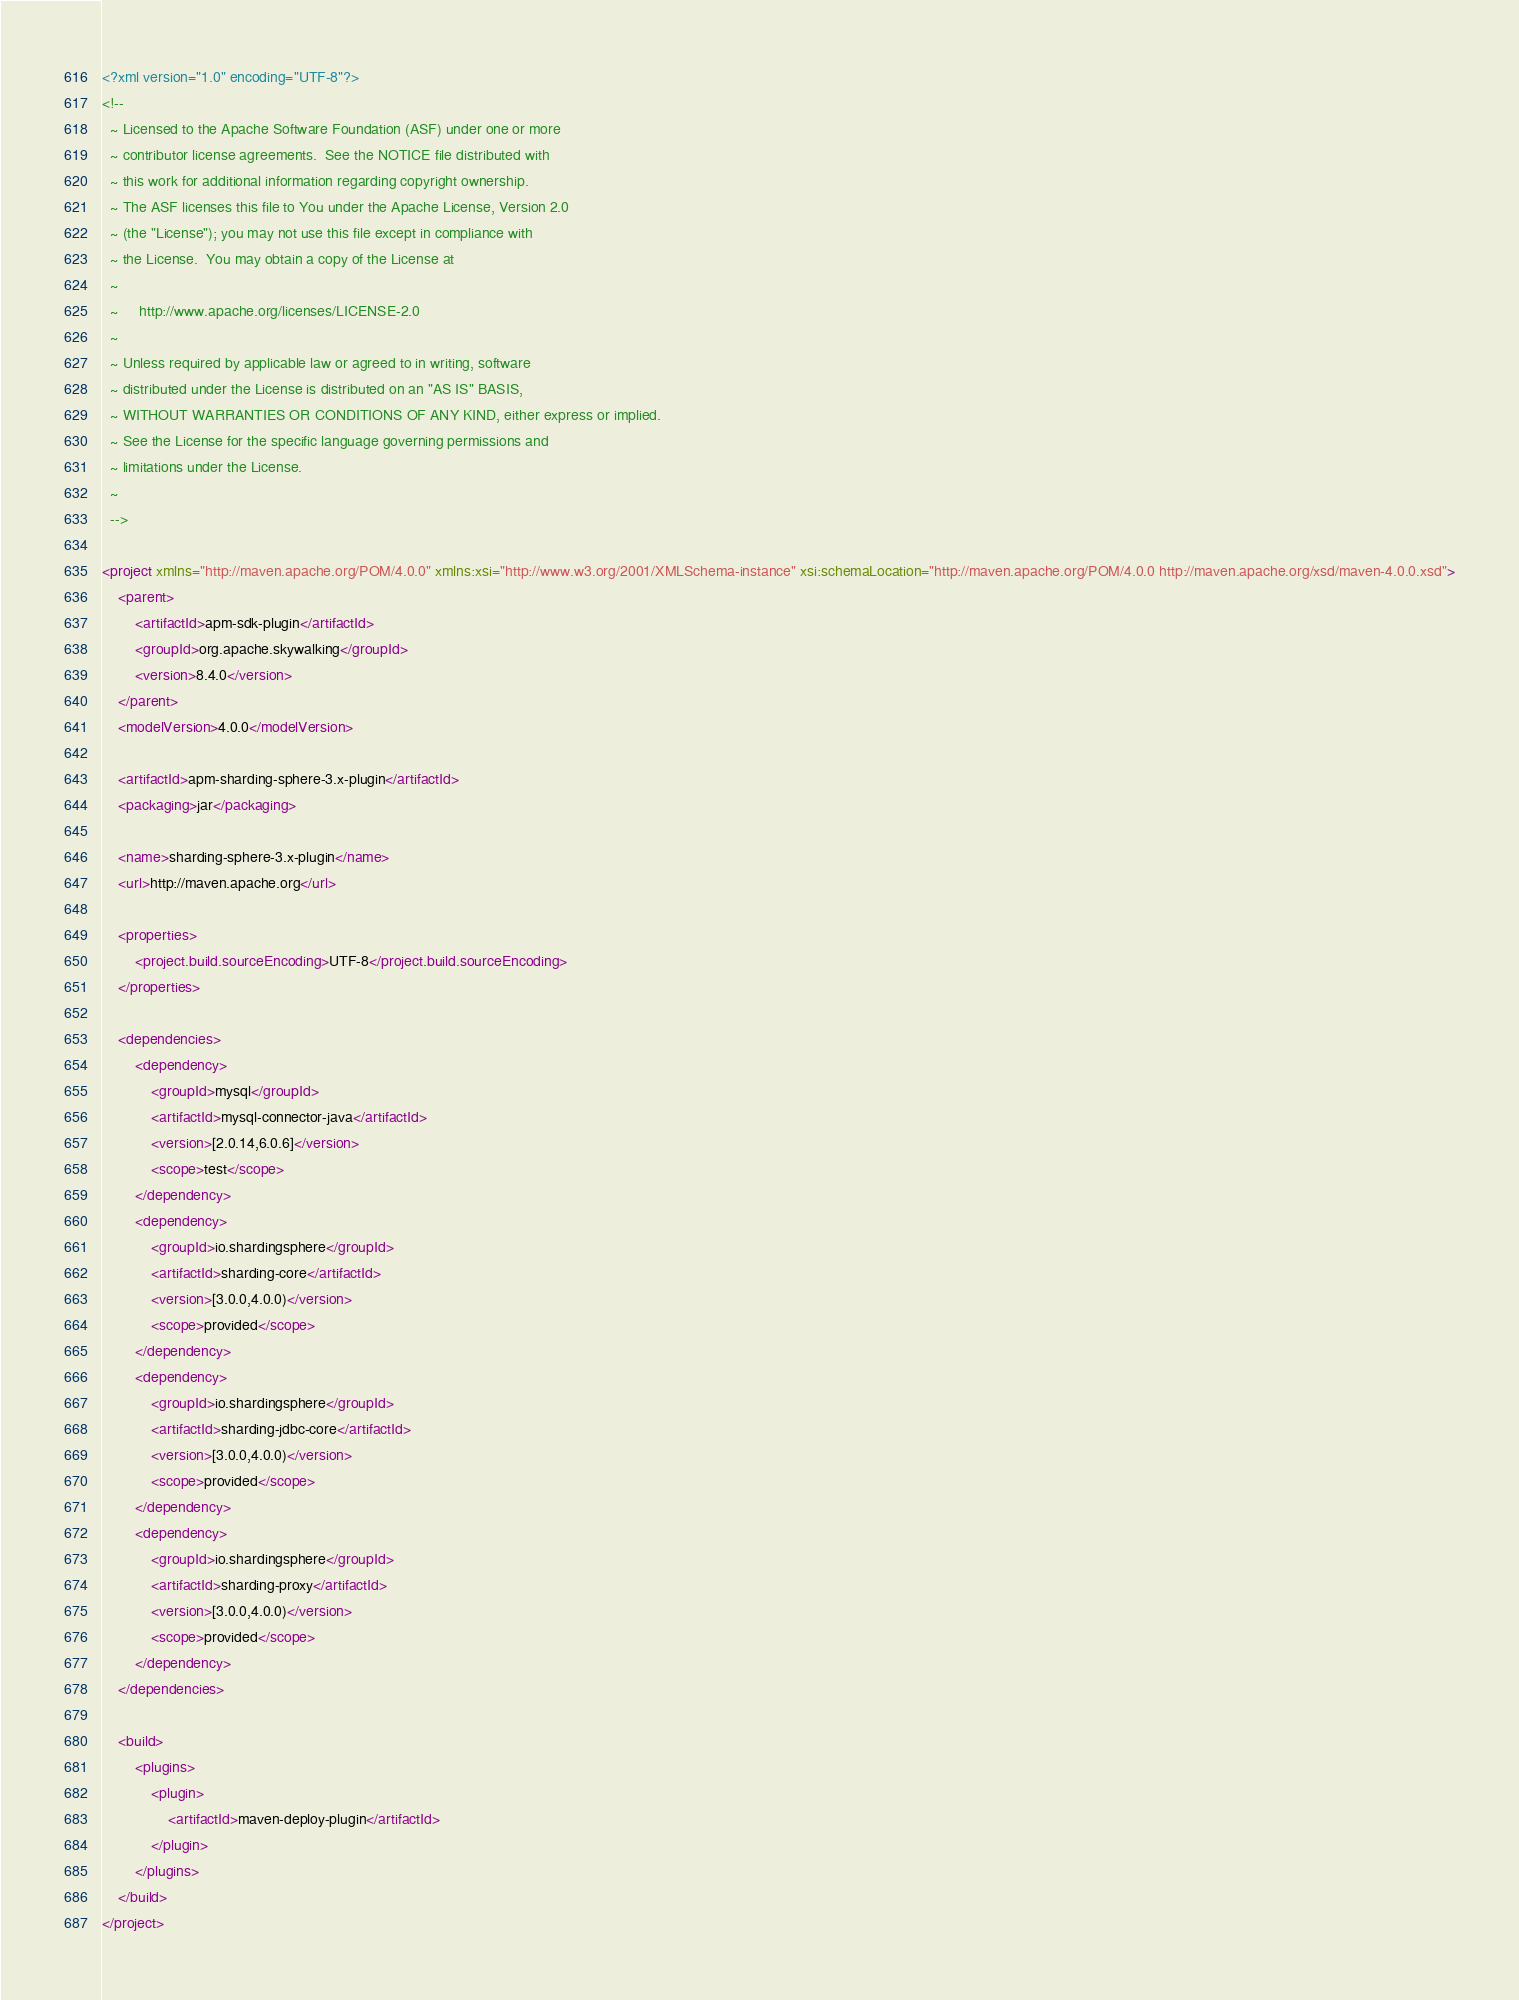Convert code to text. <code><loc_0><loc_0><loc_500><loc_500><_XML_><?xml version="1.0" encoding="UTF-8"?>
<!--
  ~ Licensed to the Apache Software Foundation (ASF) under one or more
  ~ contributor license agreements.  See the NOTICE file distributed with
  ~ this work for additional information regarding copyright ownership.
  ~ The ASF licenses this file to You under the Apache License, Version 2.0
  ~ (the "License"); you may not use this file except in compliance with
  ~ the License.  You may obtain a copy of the License at
  ~
  ~     http://www.apache.org/licenses/LICENSE-2.0
  ~
  ~ Unless required by applicable law or agreed to in writing, software
  ~ distributed under the License is distributed on an "AS IS" BASIS,
  ~ WITHOUT WARRANTIES OR CONDITIONS OF ANY KIND, either express or implied.
  ~ See the License for the specific language governing permissions and
  ~ limitations under the License.
  ~
  -->

<project xmlns="http://maven.apache.org/POM/4.0.0" xmlns:xsi="http://www.w3.org/2001/XMLSchema-instance" xsi:schemaLocation="http://maven.apache.org/POM/4.0.0 http://maven.apache.org/xsd/maven-4.0.0.xsd">
    <parent>
        <artifactId>apm-sdk-plugin</artifactId>
        <groupId>org.apache.skywalking</groupId>
        <version>8.4.0</version>
    </parent>
    <modelVersion>4.0.0</modelVersion>

    <artifactId>apm-sharding-sphere-3.x-plugin</artifactId>
    <packaging>jar</packaging>

    <name>sharding-sphere-3.x-plugin</name>
    <url>http://maven.apache.org</url>

    <properties>
        <project.build.sourceEncoding>UTF-8</project.build.sourceEncoding>
    </properties>

    <dependencies>
        <dependency>
            <groupId>mysql</groupId>
            <artifactId>mysql-connector-java</artifactId>
            <version>[2.0.14,6.0.6]</version>
            <scope>test</scope>
        </dependency>
        <dependency>
            <groupId>io.shardingsphere</groupId>
            <artifactId>sharding-core</artifactId>
            <version>[3.0.0,4.0.0)</version>
            <scope>provided</scope>
        </dependency>
        <dependency>
            <groupId>io.shardingsphere</groupId>
            <artifactId>sharding-jdbc-core</artifactId>
            <version>[3.0.0,4.0.0)</version>
            <scope>provided</scope>
        </dependency>
        <dependency>
            <groupId>io.shardingsphere</groupId>
            <artifactId>sharding-proxy</artifactId>
            <version>[3.0.0,4.0.0)</version>
            <scope>provided</scope>
        </dependency>
    </dependencies>

    <build>
        <plugins>
            <plugin>
                <artifactId>maven-deploy-plugin</artifactId>
            </plugin>
        </plugins>
    </build>
</project>
</code> 